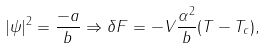<formula> <loc_0><loc_0><loc_500><loc_500>| \psi | ^ { 2 } = \frac { - a } { b } \Rightarrow \delta F = - V \frac { \alpha ^ { 2 } } { b } ( T - T _ { c } ) ,</formula> 